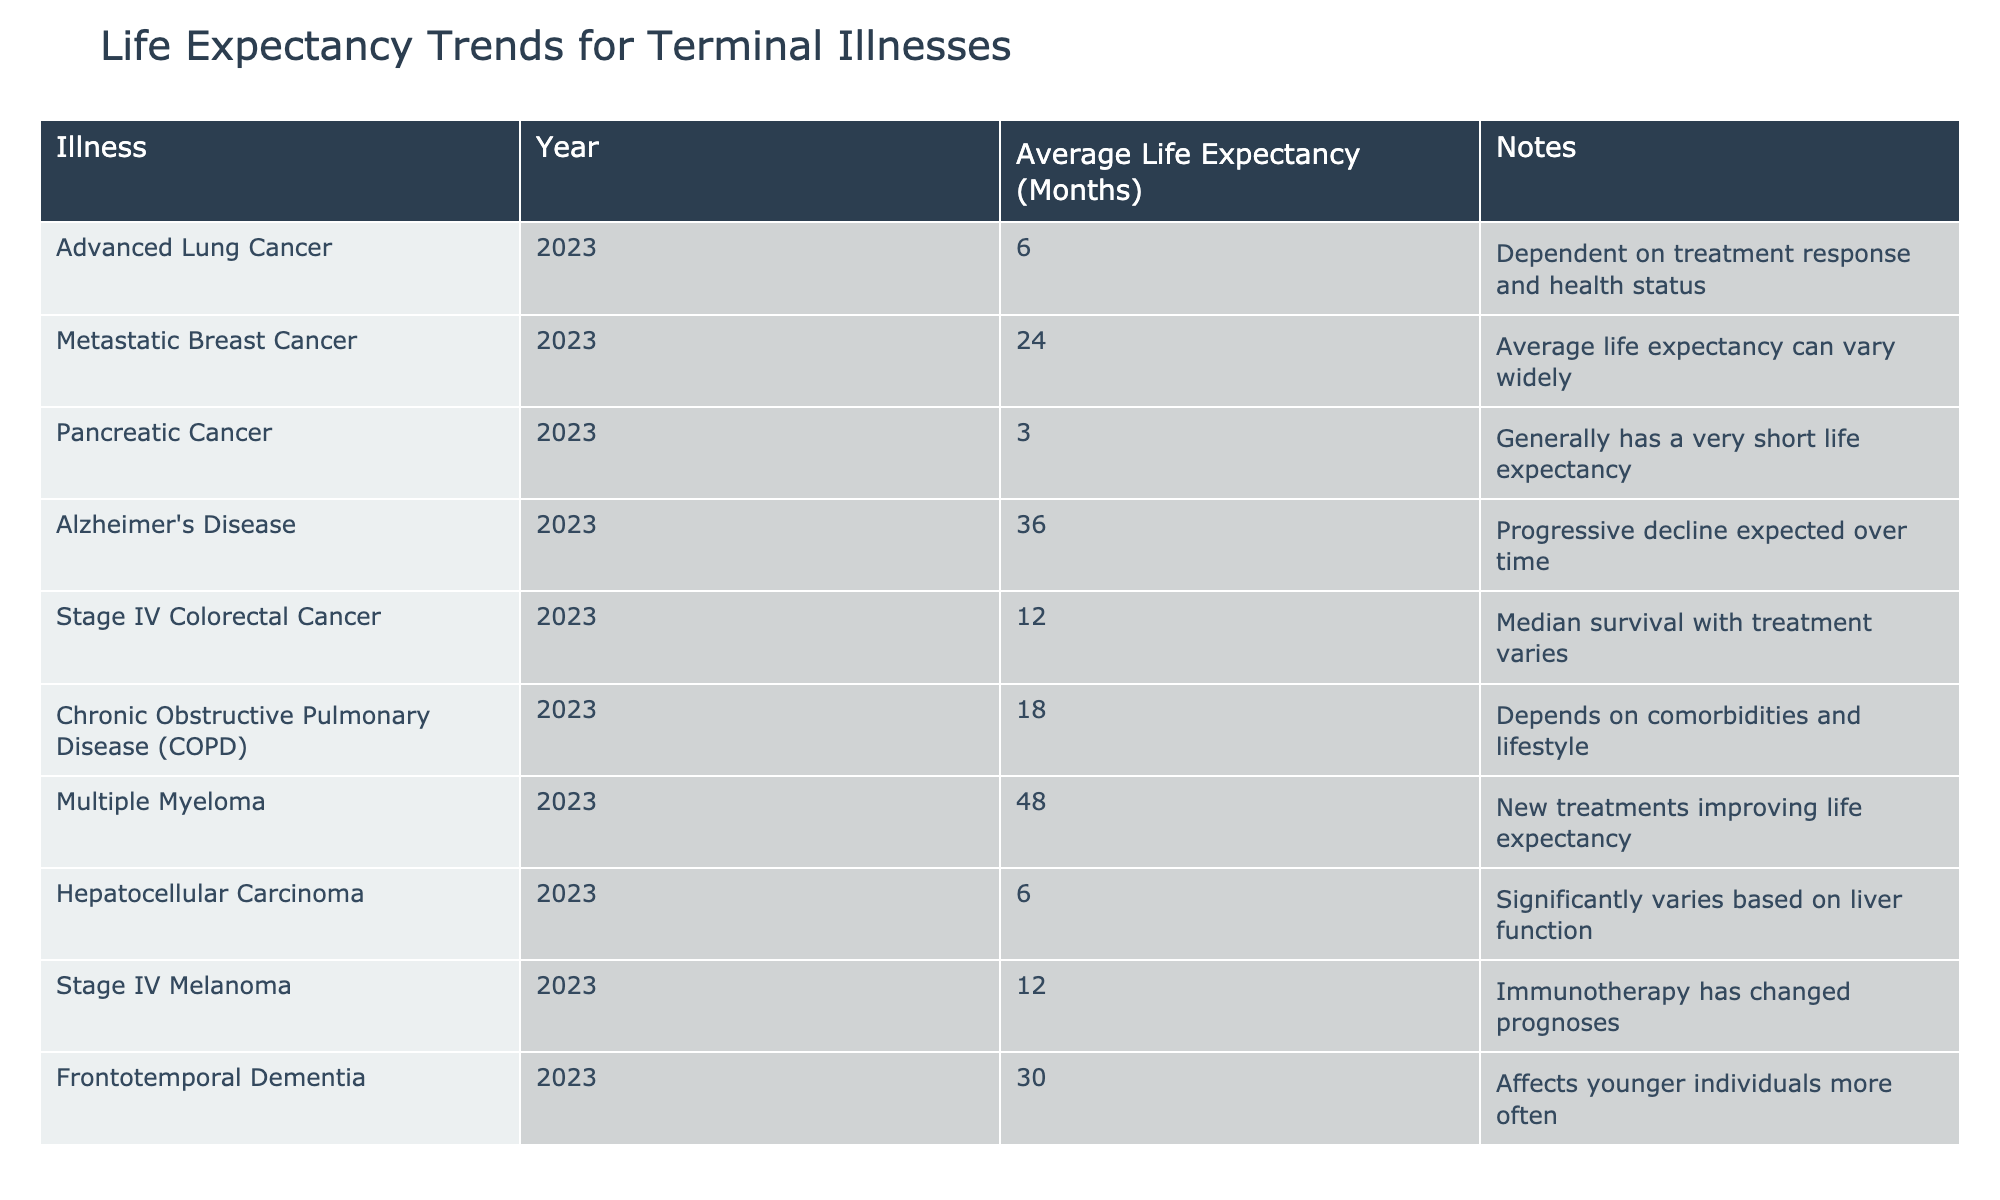What is the average life expectancy for Pancreatic Cancer? According to the table, the average life expectancy for Pancreatic Cancer in 2023 is 3 months.
Answer: 3 months Which illness has the longest average life expectancy listed in the table? The longest average life expectancy in the table is for Multiple Myeloma, which is 48 months.
Answer: 48 months Does Stage IV Colorectal Cancer have a shorter average life expectancy than Advanced Lung Cancer? The average life expectancy for Stage IV Colorectal Cancer is 12 months, whereas for Advanced Lung Cancer, it is 6 months. Since 12 is greater than 6, the answer is yes.
Answer: Yes What is the difference in average life expectancy between Alzheimer's Disease and Chronic Obstructive Pulmonary Disease? The average life expectancy for Alzheimer's Disease is 36 months and for Chronic Obstructive Pulmonary Disease, it is 18 months. The difference is 36 - 18 = 18 months.
Answer: 18 months Is it true that Metastatic Breast Cancer has a shorter average life expectancy than Multiple Myeloma? The average life expectancy for Metastatic Breast Cancer is 24 months, while for Multiple Myeloma, it is 48 months. Since 24 is less than 48, the statement is true.
Answer: Yes What is the overall average life expectancy of all the illnesses listed in the table? To find the overall average, we sum the life expectancies: 6 + 24 + 3 + 36 + 12 + 18 + 48 + 6 + 12 + 30 =  169 months. Since there are 10 illnesses, we divide 169 by 10, which gives us approximately 16.9 months.
Answer: 16.9 months Compare the average life expectancy of Frontotemporal Dementia and Pancreatic Cancer. Which one has a higher average life expectancy? Frontotemporal Dementia has an average life expectancy of 30 months, whereas Pancreatic Cancer has 3 months. Since 30 is greater than 3, Frontotemporal Dementia has a higher average life expectancy.
Answer: Frontotemporal Dementia How many illnesses listed have an average life expectancy of less than 12 months? The illnesses with an average life expectancy less than 12 months are Advanced Lung Cancer (6 months), Pancreatic Cancer (3 months), and Hepatocellular Carcinoma (6 months). This totals to 3 illnesses.
Answer: 3 illnesses 